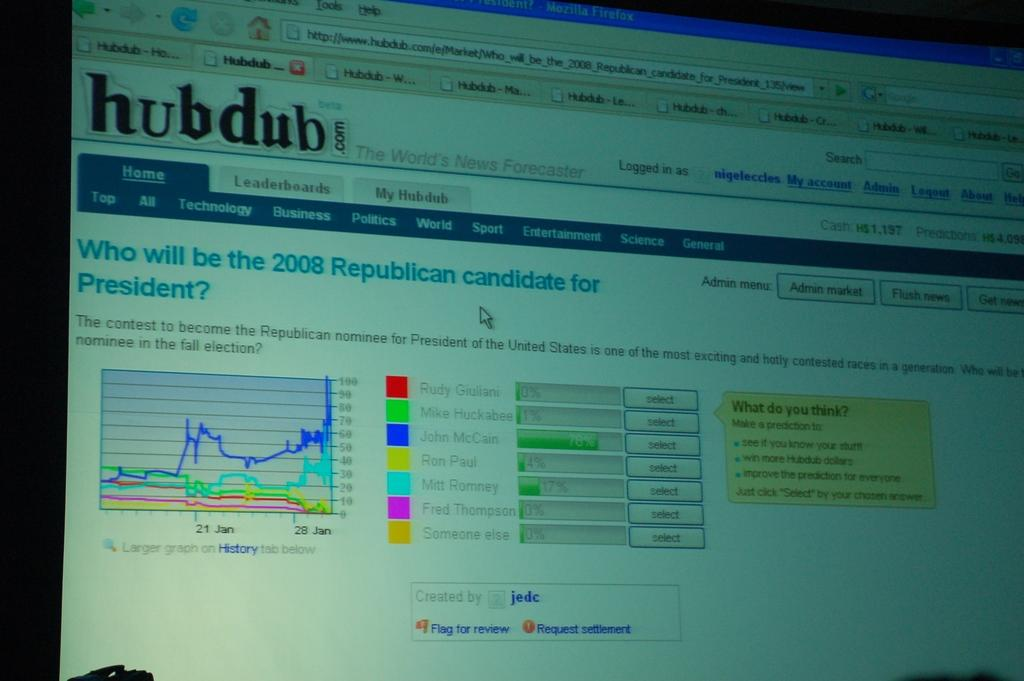Provide a one-sentence caption for the provided image. a computer monitor screen open to a Hub Dub page. 